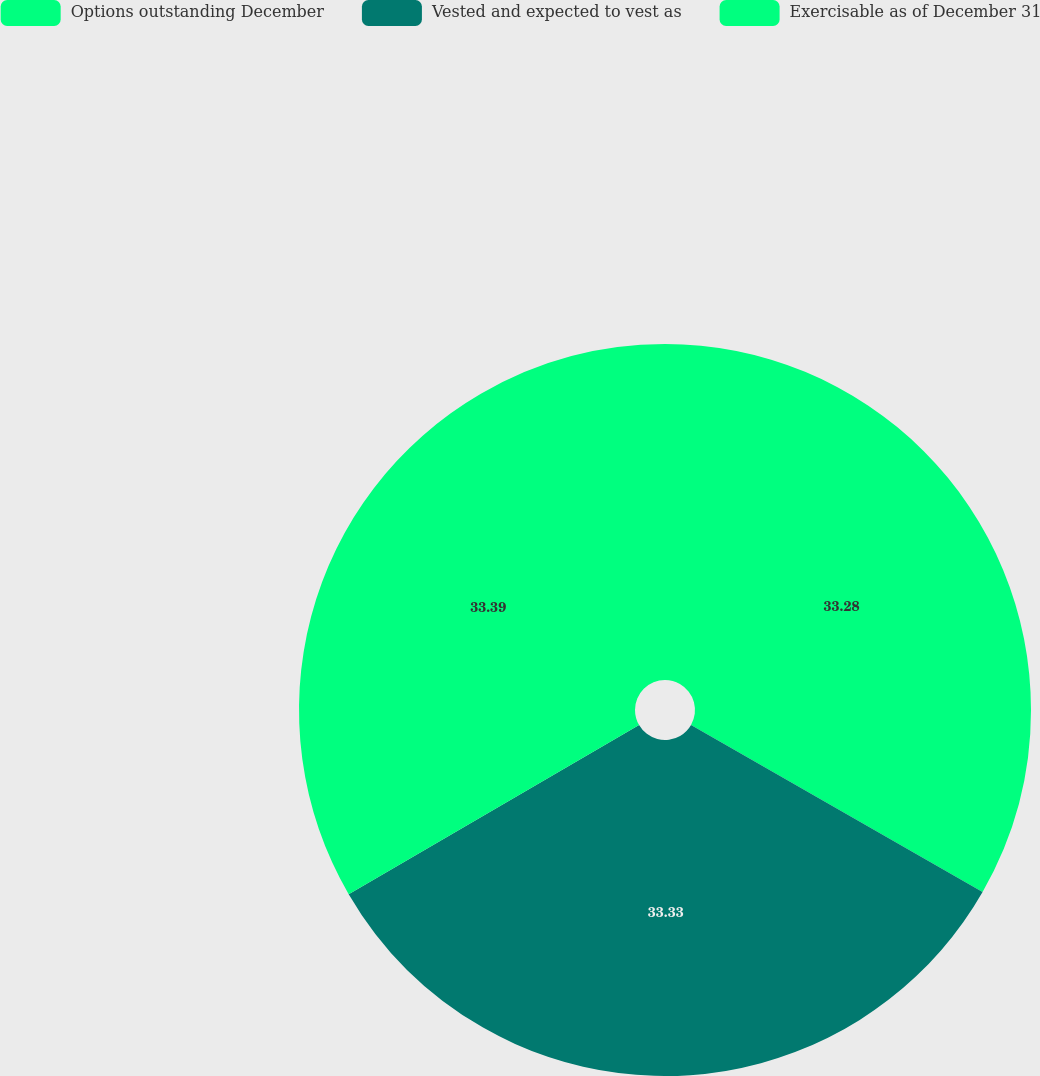<chart> <loc_0><loc_0><loc_500><loc_500><pie_chart><fcel>Options outstanding December<fcel>Vested and expected to vest as<fcel>Exercisable as of December 31<nl><fcel>33.28%<fcel>33.33%<fcel>33.39%<nl></chart> 